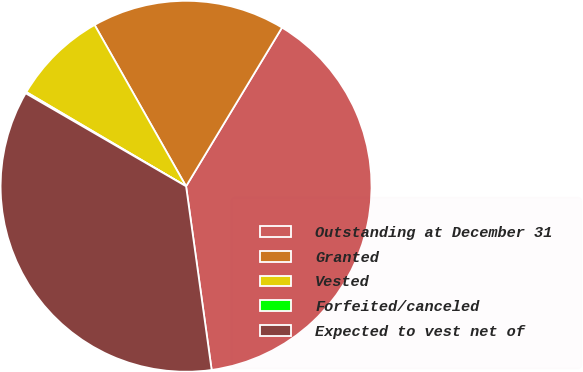<chart> <loc_0><loc_0><loc_500><loc_500><pie_chart><fcel>Outstanding at December 31<fcel>Granted<fcel>Vested<fcel>Forfeited/canceled<fcel>Expected to vest net of<nl><fcel>39.14%<fcel>16.86%<fcel>8.31%<fcel>0.12%<fcel>35.56%<nl></chart> 